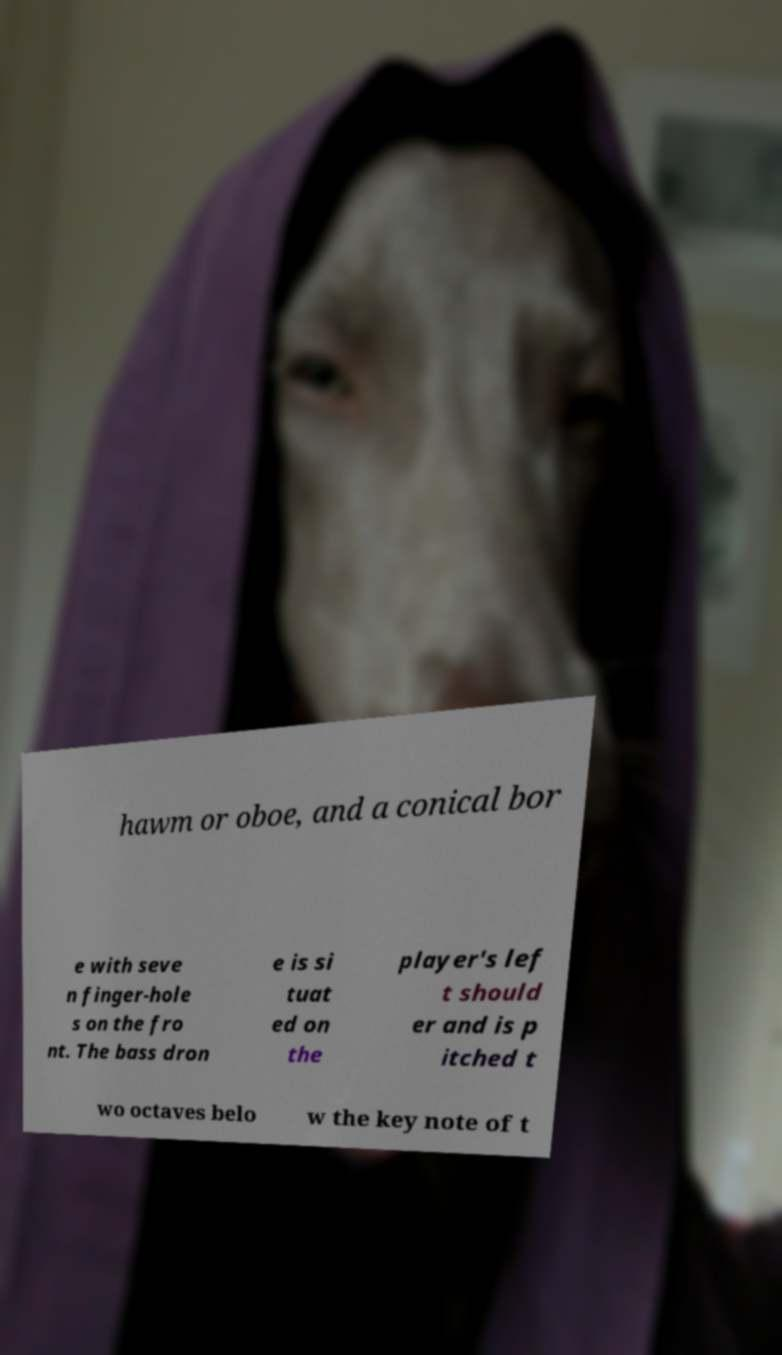I need the written content from this picture converted into text. Can you do that? hawm or oboe, and a conical bor e with seve n finger-hole s on the fro nt. The bass dron e is si tuat ed on the player's lef t should er and is p itched t wo octaves belo w the key note of t 